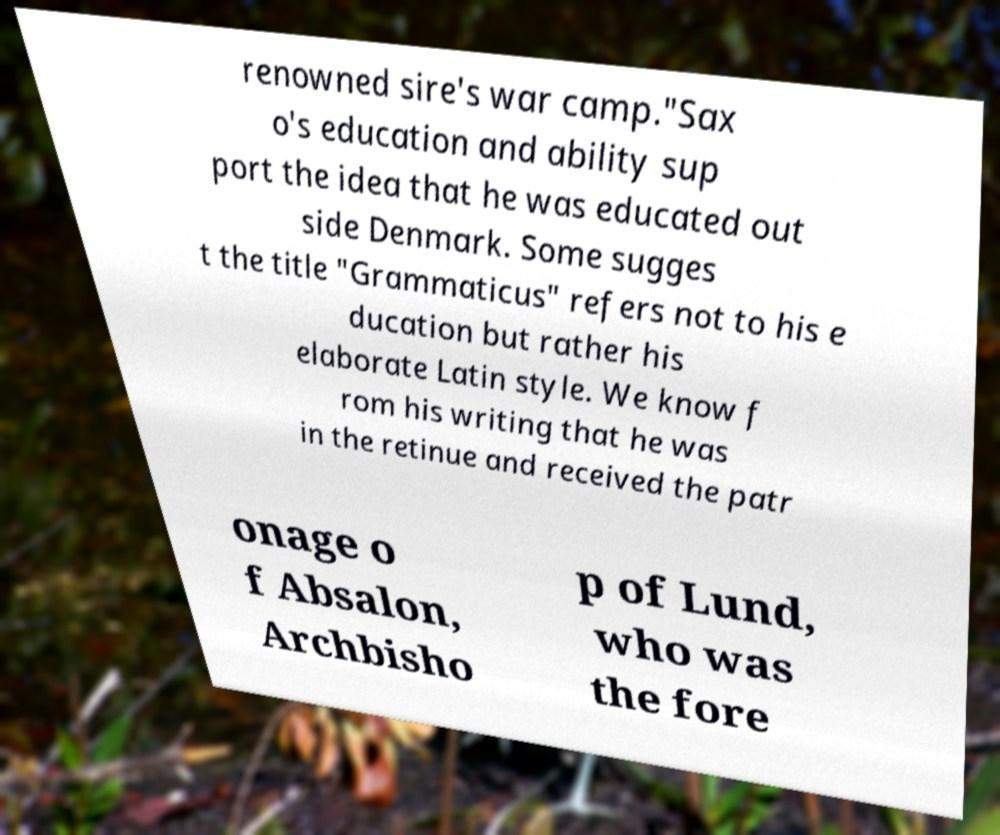For documentation purposes, I need the text within this image transcribed. Could you provide that? renowned sire's war camp."Sax o's education and ability sup port the idea that he was educated out side Denmark. Some sugges t the title "Grammaticus" refers not to his e ducation but rather his elaborate Latin style. We know f rom his writing that he was in the retinue and received the patr onage o f Absalon, Archbisho p of Lund, who was the fore 